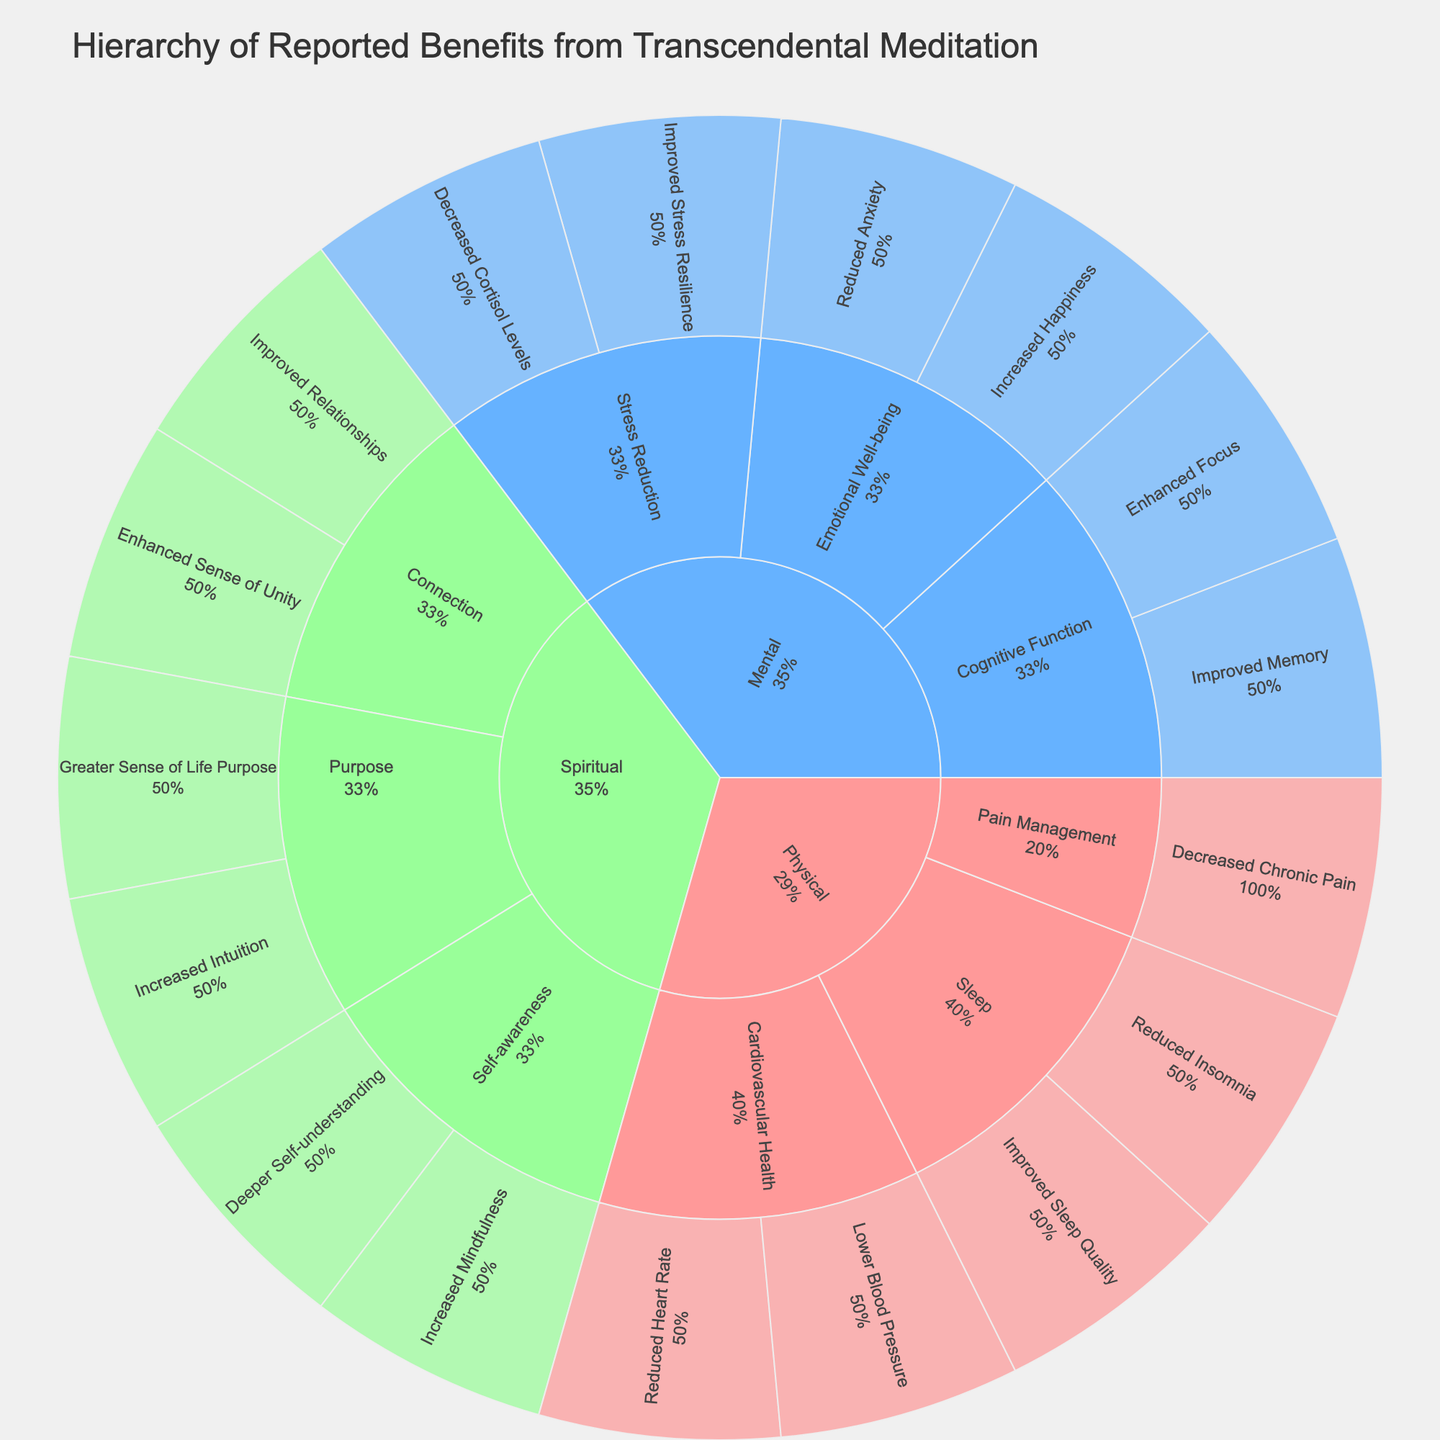What are the three main categories in the sunburst plot? The sunburst plot shows three main sections, each representing a primary category. They are labeled with distinct colors that signify different aspects.
Answer: Physical, Mental, Spiritual Which category has 'Improved Sleep Quality' as a benefit? By examining the subcategories under each main category, 'Improved Sleep Quality' is found under the 'Physical' category.
Answer: Physical How many benefits are listed under the 'Mental' category? To determine this, count all the benefits under the subcategories of 'Mental'. The subcategories are 'Stress Reduction', 'Cognitive Function', and 'Emotional Well-being', with a total of six benefits.
Answer: Six Which subcategory under 'Spiritual' contains the highest number of benefits? Look at all subcategories under 'Spiritual' and count the benefits in each. 'Self-awareness' and 'Purpose' each have two benefits, whereas 'Connection' has three.
Answer: Connection What percentage of benefits fall under 'Physical'? Check the proportion of the segments belonging to 'Physical' relative to the total plot, which is visually indicated by the percentage provided.
Answer: The exact percentage may vary but it's visibly a significant chunk How do benefits related to 'Sleep' compare to those related to 'Stress Reduction'? Count the benefits under each subcategory. 'Sleep' under 'Physical' has two benefits: 'Improved Sleep Quality' and 'Reduced Insomnia'. 'Stress Reduction' under 'Mental' also has two: 'Decreased Cortisol Levels' and 'Improved Stress Resilience'.
Answer: Both have two benefits What subcategory includes 'Decreased Chronic Pain'? Locate the benefit 'Decreased Chronic Pain' in the sunburst plot and identify its subcategory, which is 'Pain Management' under the 'Physical' category.
Answer: Pain Management What are the benefits listed under 'Emotional Well-being'? Identify the subcategory 'Emotional Well-being' under the 'Mental' category and list the corresponding benefits: 'Reduced Anxiety' and 'Increased Happiness'.
Answer: Reduced Anxiety, Increased Happiness Which category has the most diverse subcategories? Count the number of varied subcategories under each main category. 'Spiritual' has subcategories 'Self-awareness', 'Connection', and 'Purpose', totaling three. 'Physical' and 'Mental' both have fewer.
Answer: Spiritual Compare the benefits under 'Cognitive Function' to those under 'Cardiovascular Health'. List the benefits under 'Cognitive Function' ('Enhanced Focus', 'Improved Memory') and 'Cardiovascular Health' ('Lower Blood Pressure', 'Reduced Heart Rate'). Both subcategories offer two benefits each.
Answer: Both have two benefits 